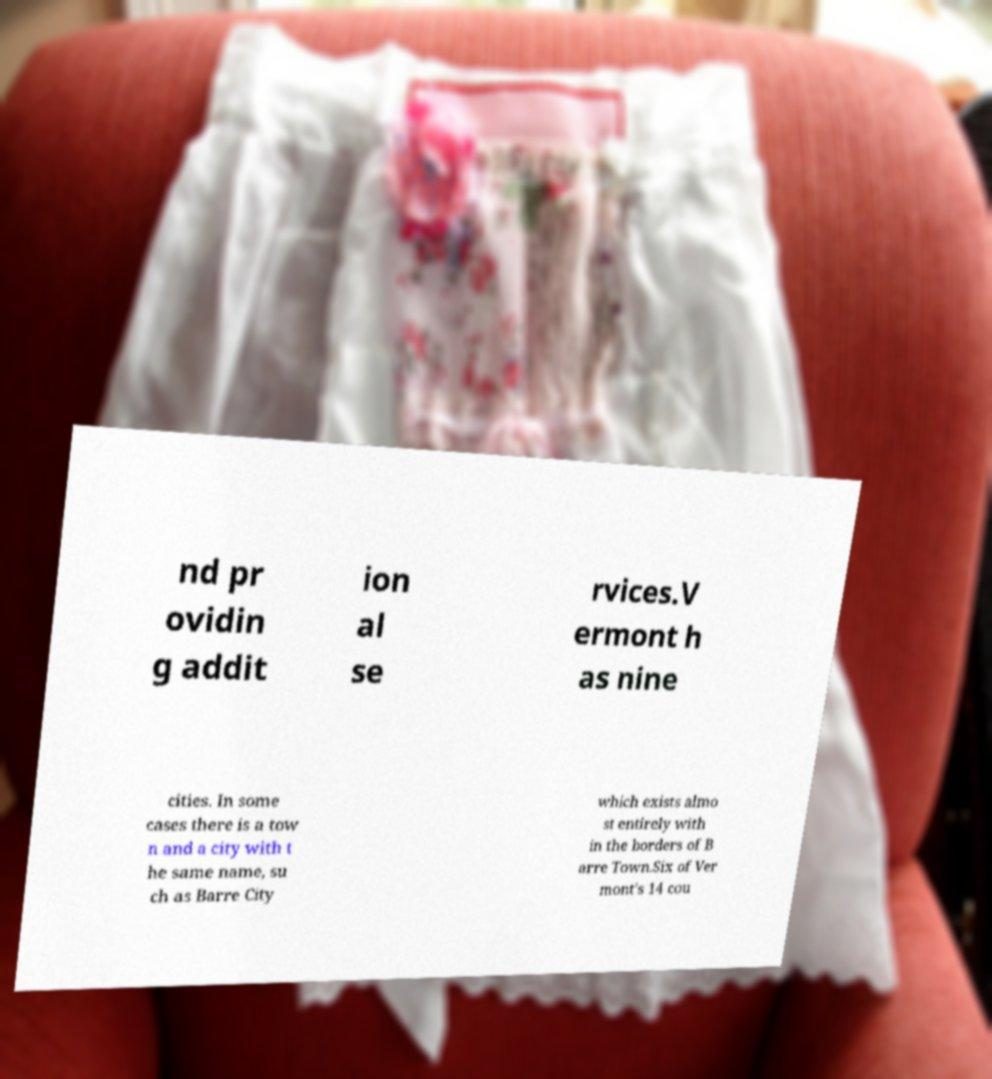Please read and relay the text visible in this image. What does it say? nd pr ovidin g addit ion al se rvices.V ermont h as nine cities. In some cases there is a tow n and a city with t he same name, su ch as Barre City which exists almo st entirely with in the borders of B arre Town.Six of Ver mont's 14 cou 